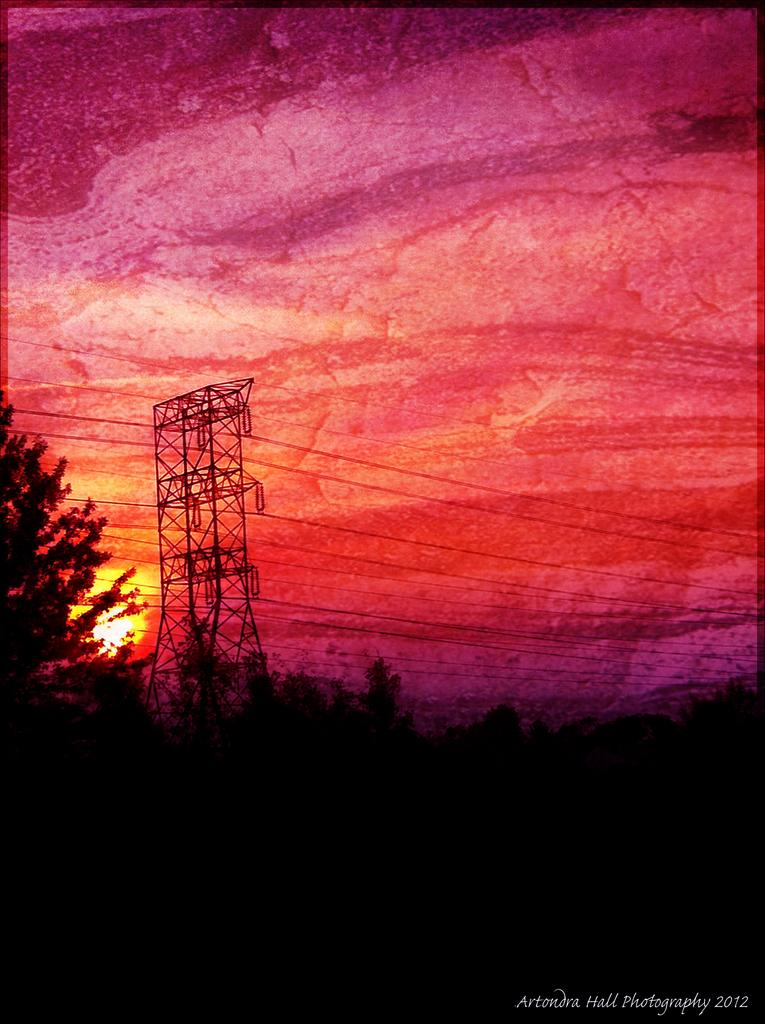What type of natural elements can be seen in the image? There are trees in the image. What man-made structures are present in the image? There are poles and wires in the image. What is the color of the sky in the image? The sky is red in color. Is there any text or image in a specific location in the image? Yes, there is text or an image in the right bottom corner of the image. How much does the tent cost in the image? There is no tent present in the image, so it is not possible to determine its cost. 